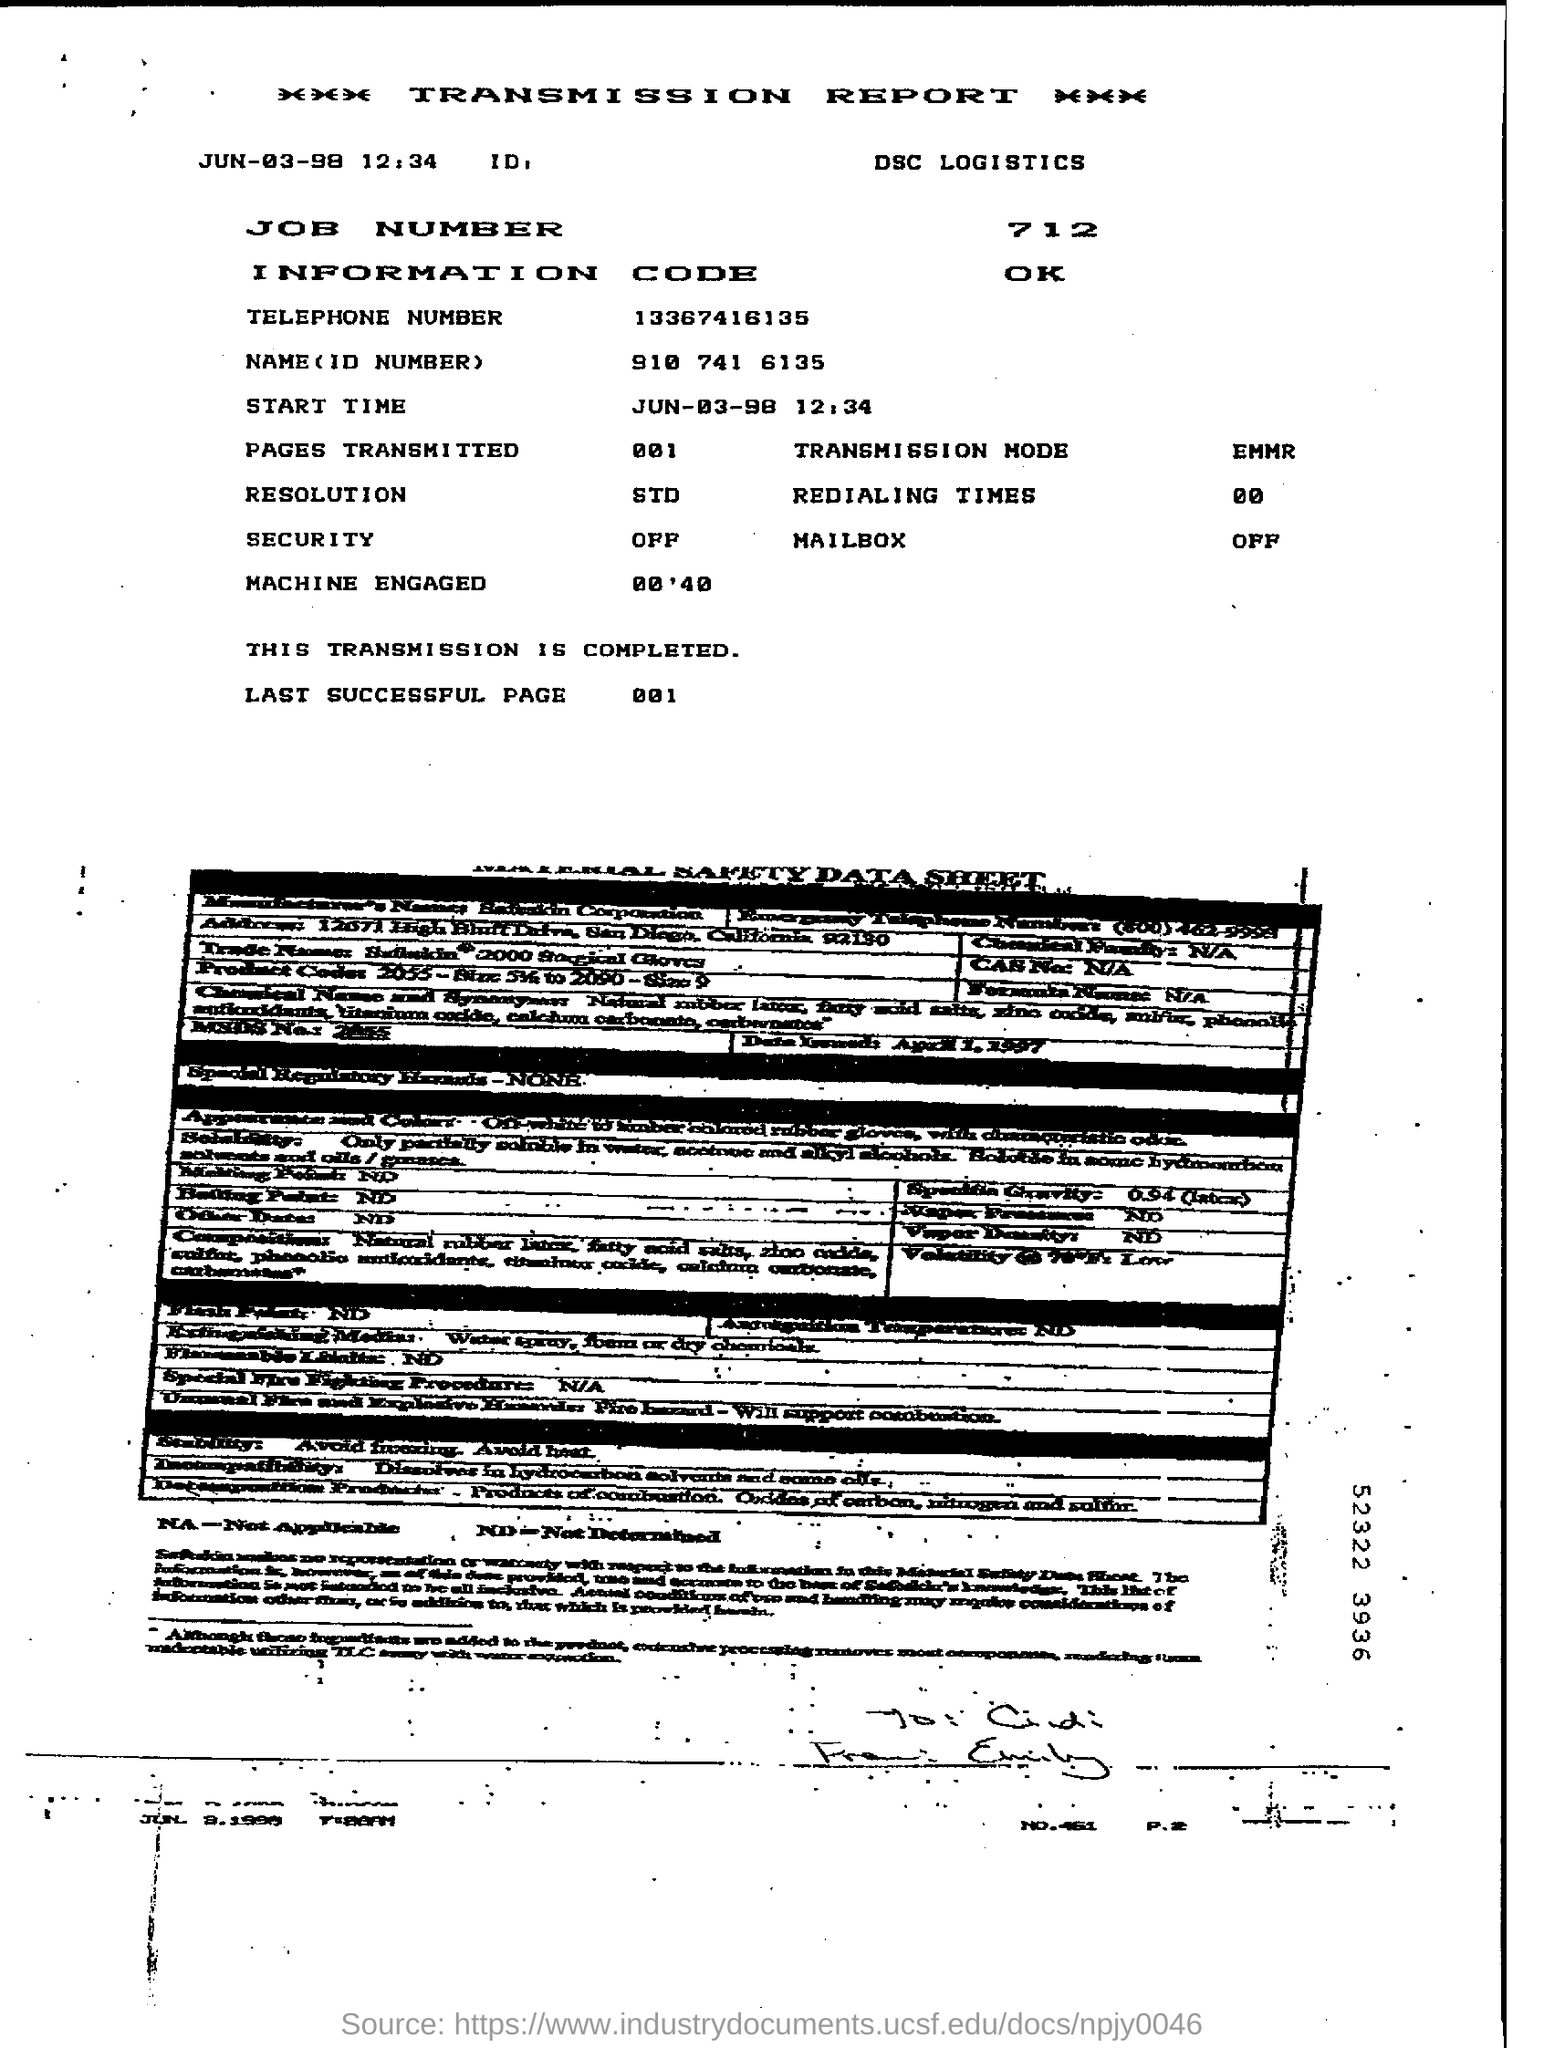Point out several critical features in this image. The start time mentioned is JUN-03-98 12:34. The information code mentioned is OK. Transmission mode refers to the method by which data is transmitted over a communication channel, and it is typically expressed in the format Ethernet Media Mode and Registration (EMMR). The job number is 712. 